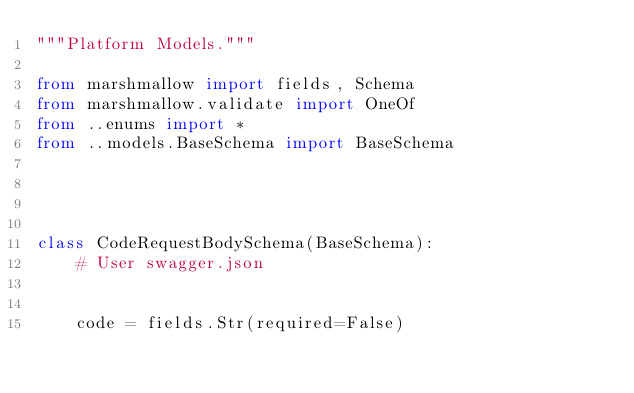Convert code to text. <code><loc_0><loc_0><loc_500><loc_500><_Python_>"""Platform Models."""

from marshmallow import fields, Schema
from marshmallow.validate import OneOf
from ..enums import *
from ..models.BaseSchema import BaseSchema




class CodeRequestBodySchema(BaseSchema):
    # User swagger.json

    
    code = fields.Str(required=False)
    

</code> 